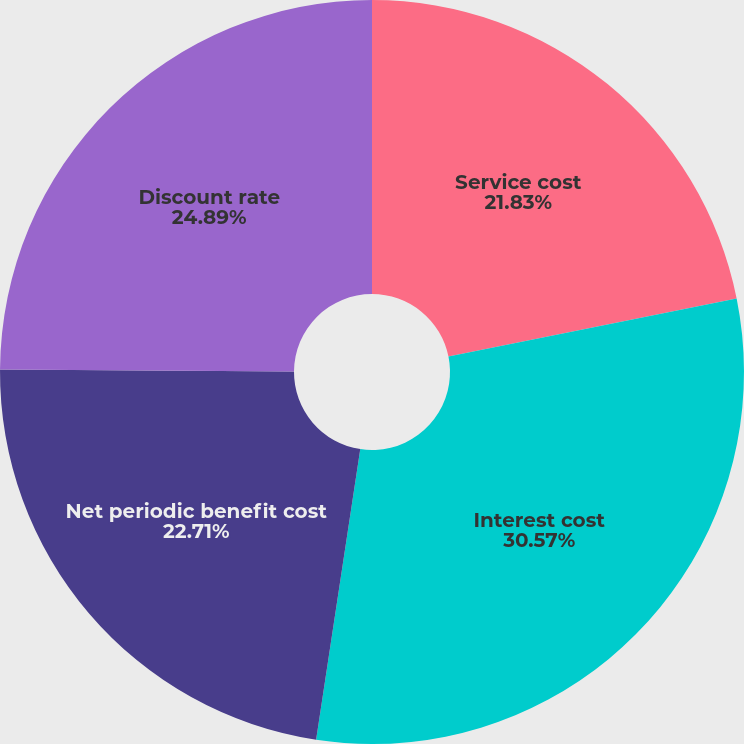Convert chart. <chart><loc_0><loc_0><loc_500><loc_500><pie_chart><fcel>Service cost<fcel>Interest cost<fcel>Net periodic benefit cost<fcel>Discount rate<nl><fcel>21.83%<fcel>30.57%<fcel>22.71%<fcel>24.89%<nl></chart> 